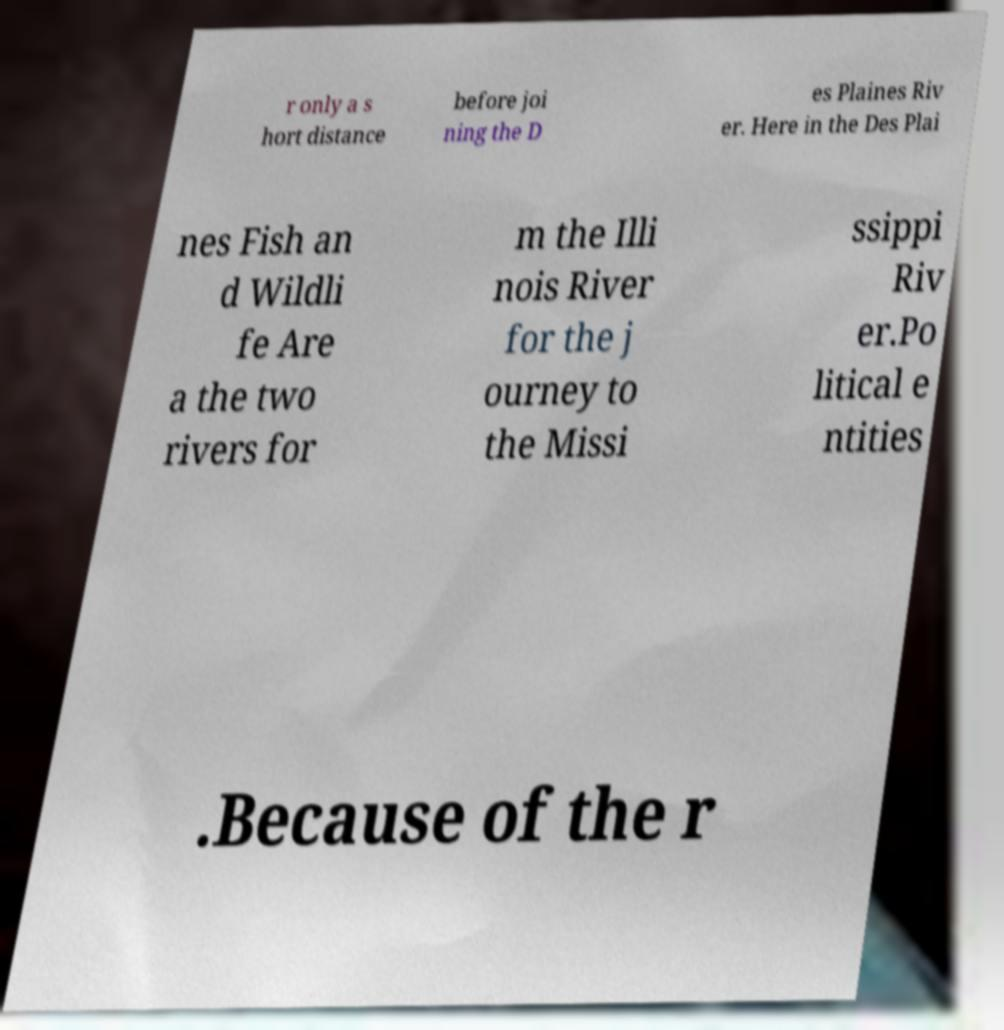Could you assist in decoding the text presented in this image and type it out clearly? r only a s hort distance before joi ning the D es Plaines Riv er. Here in the Des Plai nes Fish an d Wildli fe Are a the two rivers for m the Illi nois River for the j ourney to the Missi ssippi Riv er.Po litical e ntities .Because of the r 